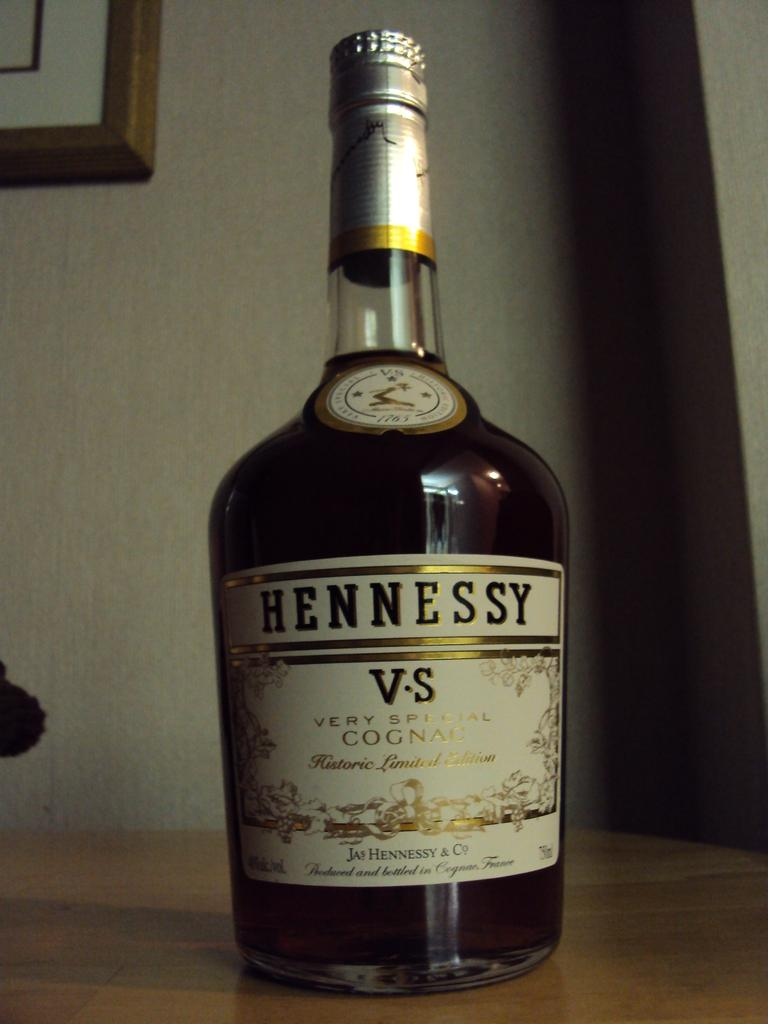<image>
Summarize the visual content of the image. A bottle of Hennessy VS "very special" cognac sits on a wood surface. 